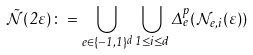<formula> <loc_0><loc_0><loc_500><loc_500>\tilde { \mathcal { N } } ( 2 \varepsilon ) \colon = \bigcup _ { e \in \{ - 1 , 1 \} ^ { d } } \bigcup _ { 1 \leq i \leq d } \Delta _ { e } ^ { p } ( \mathcal { N } _ { e , i } ( \varepsilon ) )</formula> 